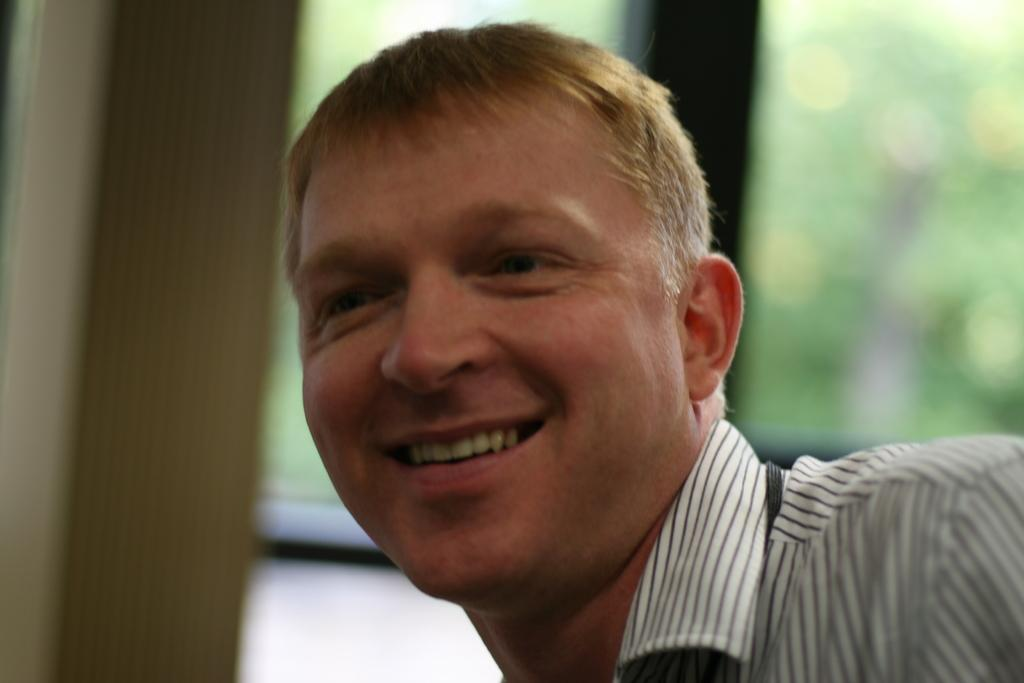Who is present in the image? There is a man in the image. What is the man wearing? The man is wearing clothes. What is the man's facial expression? The man is smiling. Can you describe the background of the image? The background of the image is blurred. How much wealth does the door in the image possess? There is no door present in the image, so it is not possible to determine its wealth. 